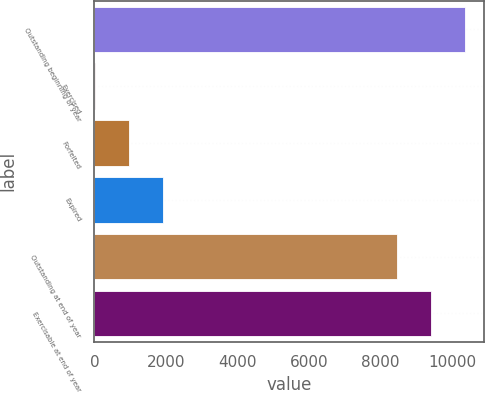Convert chart to OTSL. <chart><loc_0><loc_0><loc_500><loc_500><bar_chart><fcel>Outstanding beginning of year<fcel>Exercised<fcel>Forfeited<fcel>Expired<fcel>Outstanding at end of year<fcel>Exercisable at end of year<nl><fcel>10367<fcel>12<fcel>965.5<fcel>1919<fcel>8460<fcel>9413.5<nl></chart> 